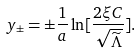Convert formula to latex. <formula><loc_0><loc_0><loc_500><loc_500>y _ { \pm } = \pm \frac { 1 } { a } \ln [ \frac { 2 \xi C } { \sqrt { \widetilde { \Lambda } } } ] .</formula> 